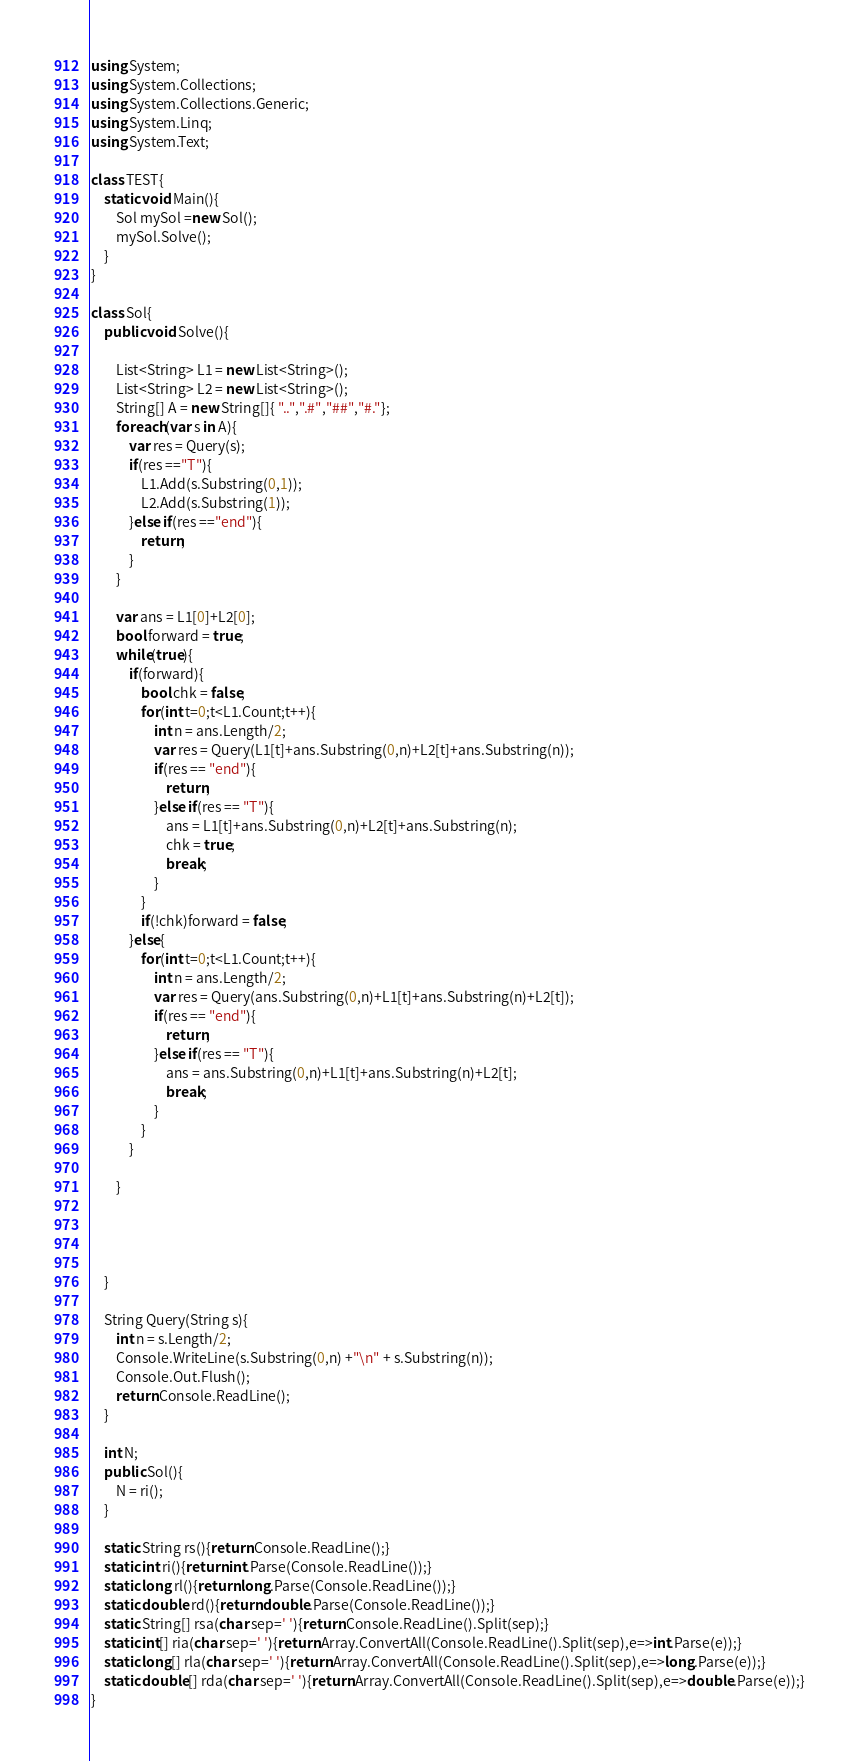<code> <loc_0><loc_0><loc_500><loc_500><_C#_>using System;
using System.Collections;
using System.Collections.Generic;
using System.Linq;
using System.Text;

class TEST{
	static void Main(){
		Sol mySol =new Sol();
		mySol.Solve();
	}
}

class Sol{
	public void Solve(){
		
		List<String> L1 = new List<String>();
		List<String> L2 = new List<String>();
		String[] A = new String[]{ "..",".#","##","#."};
		foreach(var s in A){
			var res = Query(s);
			if(res =="T"){
				L1.Add(s.Substring(0,1));
				L2.Add(s.Substring(1));
			}else if(res =="end"){
				return;
			}
		}
		
		var ans = L1[0]+L2[0];
		bool forward = true;
		while(true){
			if(forward){
				bool chk = false;
				for(int t=0;t<L1.Count;t++){
					int n = ans.Length/2;
					var res = Query(L1[t]+ans.Substring(0,n)+L2[t]+ans.Substring(n));
					if(res == "end"){
						return;
					}else if(res == "T"){
						ans = L1[t]+ans.Substring(0,n)+L2[t]+ans.Substring(n);
						chk = true;
						break;
					}
				}
				if(!chk)forward = false;
			}else{
				for(int t=0;t<L1.Count;t++){
					int n = ans.Length/2;
					var res = Query(ans.Substring(0,n)+L1[t]+ans.Substring(n)+L2[t]);
					if(res == "end"){
						return;
					}else if(res == "T"){
						ans = ans.Substring(0,n)+L1[t]+ans.Substring(n)+L2[t];
						break;
					}
				}
			}
			
		}
		
		
		
		
	}
	
	String Query(String s){
		int n = s.Length/2;
		Console.WriteLine(s.Substring(0,n) +"\n" + s.Substring(n));
		Console.Out.Flush();
		return Console.ReadLine();
	}
	
	int N;
	public Sol(){
		N = ri();
	}

	static String rs(){return Console.ReadLine();}
	static int ri(){return int.Parse(Console.ReadLine());}
	static long rl(){return long.Parse(Console.ReadLine());}
	static double rd(){return double.Parse(Console.ReadLine());}
	static String[] rsa(char sep=' '){return Console.ReadLine().Split(sep);}
	static int[] ria(char sep=' '){return Array.ConvertAll(Console.ReadLine().Split(sep),e=>int.Parse(e));}
	static long[] rla(char sep=' '){return Array.ConvertAll(Console.ReadLine().Split(sep),e=>long.Parse(e));}
	static double[] rda(char sep=' '){return Array.ConvertAll(Console.ReadLine().Split(sep),e=>double.Parse(e));}
}
</code> 